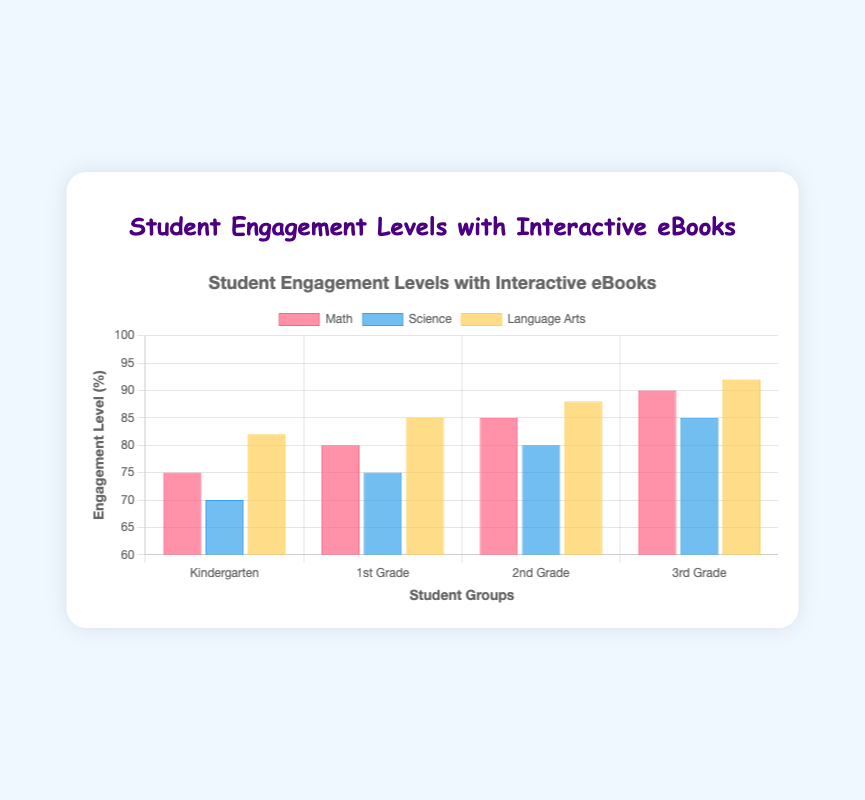Which subject has the highest engagement level among Kindergarten students? By looking at the bar heights for Kindergarten across different subjects, we see that Language Arts has the highest engagement level at 82%.
Answer: Language Arts What is the difference in engagement level between 1st Grade and 3rd Grade students in Math? The engagement level for 1st Grade in Math is 80%, and for 3rd Grade, it is 90%. The difference is 90% - 80% = 10%.
Answer: 10% Which student group has the lowest overall engagement level in Science? By comparing the engagement levels in Science for all student groups, we find that Kindergarten has the lowest engagement level at 70%.
Answer: Kindergarten What is the average engagement level in Language Arts across all student groups? Add the engagement levels in Language Arts for all student groups: 82% (Kindergarten) + 85% (1st Grade) + 88% (2nd Grade) + 92% (3rd Grade) = 347. Divide by the number of groups, 347 / 4 = 86.75%.
Answer: 86.75% Among 2nd Grade students, which subject shows the highest level of engagement? By looking at the bar heights for 2nd Grade, Language Arts has the highest engagement level at 88%.
Answer: Language Arts Is the engagement level in Science for 3rd Grade students higher or lower than in Math for 2nd Grade students? The engagement level in Science for 3rd Grade is 85%, and in Math for 2nd Grade is 85%. Since they are the same, it's neither higher nor lower.
Answer: Equal How much did the engagement level increase from Kindergarten to 3rd Grade in Science? The engagement level for Kindergarten in Science is 70%, and for 3rd Grade, it is 85%. The increase is 85% - 70% = 15%.
Answer: 15% What is the total engagement level for 1st Grade across all subjects? Add the engagement levels in 1st Grade for all subjects: 80% (Math) + 75% (Science) + 85% (Language Arts) = 240%.
Answer: 240% Which subject shows the least increase in engagement from Kindergarten to 3rd Grade? The increase from Kindergarten to 3rd Grade is: Math: 90% - 75% = 15%, Science: 85% - 70% = 15%, Language Arts: 92% - 82% = 10%. The least increase is in Language Arts with 10%.
Answer: Language Arts What is the median engagement level in Math across all student groups? The engagement levels for Math are 75%, 80%, 85%, and 90%. The median is the average of the two middle numbers: (80 + 85) / 2 = 82.5%.
Answer: 82.5% 